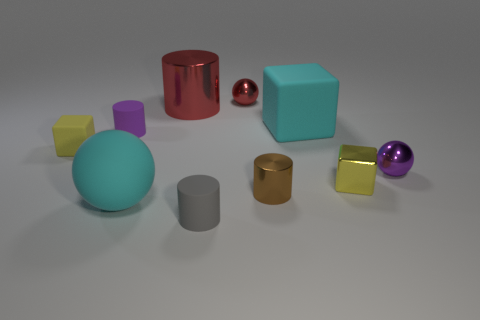Subtract all cylinders. How many objects are left? 6 Subtract all tiny brown matte cylinders. Subtract all small brown cylinders. How many objects are left? 9 Add 5 purple things. How many purple things are left? 7 Add 7 gray rubber things. How many gray rubber things exist? 8 Subtract 0 red cubes. How many objects are left? 10 